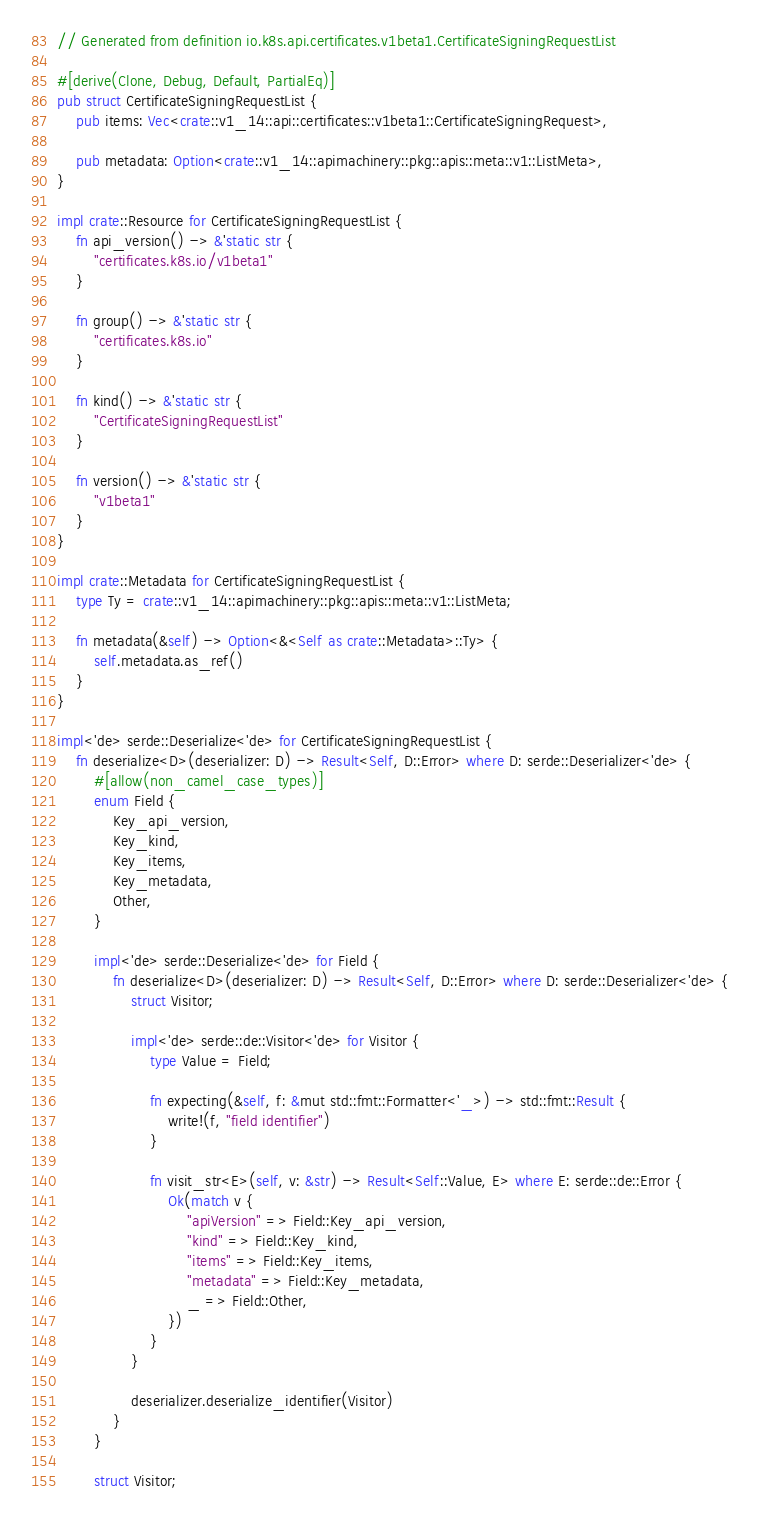Convert code to text. <code><loc_0><loc_0><loc_500><loc_500><_Rust_>// Generated from definition io.k8s.api.certificates.v1beta1.CertificateSigningRequestList

#[derive(Clone, Debug, Default, PartialEq)]
pub struct CertificateSigningRequestList {
    pub items: Vec<crate::v1_14::api::certificates::v1beta1::CertificateSigningRequest>,

    pub metadata: Option<crate::v1_14::apimachinery::pkg::apis::meta::v1::ListMeta>,
}

impl crate::Resource for CertificateSigningRequestList {
    fn api_version() -> &'static str {
        "certificates.k8s.io/v1beta1"
    }

    fn group() -> &'static str {
        "certificates.k8s.io"
    }

    fn kind() -> &'static str {
        "CertificateSigningRequestList"
    }

    fn version() -> &'static str {
        "v1beta1"
    }
}

impl crate::Metadata for CertificateSigningRequestList {
    type Ty = crate::v1_14::apimachinery::pkg::apis::meta::v1::ListMeta;

    fn metadata(&self) -> Option<&<Self as crate::Metadata>::Ty> {
        self.metadata.as_ref()
    }
}

impl<'de> serde::Deserialize<'de> for CertificateSigningRequestList {
    fn deserialize<D>(deserializer: D) -> Result<Self, D::Error> where D: serde::Deserializer<'de> {
        #[allow(non_camel_case_types)]
        enum Field {
            Key_api_version,
            Key_kind,
            Key_items,
            Key_metadata,
            Other,
        }

        impl<'de> serde::Deserialize<'de> for Field {
            fn deserialize<D>(deserializer: D) -> Result<Self, D::Error> where D: serde::Deserializer<'de> {
                struct Visitor;

                impl<'de> serde::de::Visitor<'de> for Visitor {
                    type Value = Field;

                    fn expecting(&self, f: &mut std::fmt::Formatter<'_>) -> std::fmt::Result {
                        write!(f, "field identifier")
                    }

                    fn visit_str<E>(self, v: &str) -> Result<Self::Value, E> where E: serde::de::Error {
                        Ok(match v {
                            "apiVersion" => Field::Key_api_version,
                            "kind" => Field::Key_kind,
                            "items" => Field::Key_items,
                            "metadata" => Field::Key_metadata,
                            _ => Field::Other,
                        })
                    }
                }

                deserializer.deserialize_identifier(Visitor)
            }
        }

        struct Visitor;
</code> 